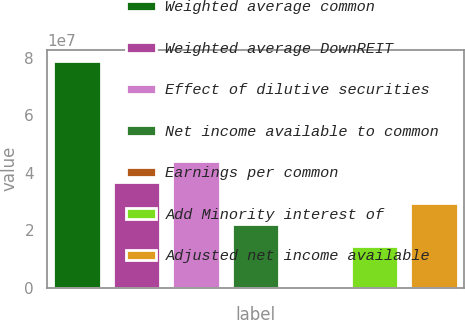<chart> <loc_0><loc_0><loc_500><loc_500><bar_chart><fcel>Weighted average common<fcel>Weighted average DownREIT<fcel>Effect of dilutive securities<fcel>Net income available to common<fcel>Earnings per common<fcel>Add Minority interest of<fcel>Adjusted net income available<nl><fcel>7.88997e+07<fcel>3.66775e+07<fcel>4.4013e+07<fcel>2.20065e+07<fcel>2.92<fcel>1.4671e+07<fcel>2.9342e+07<nl></chart> 